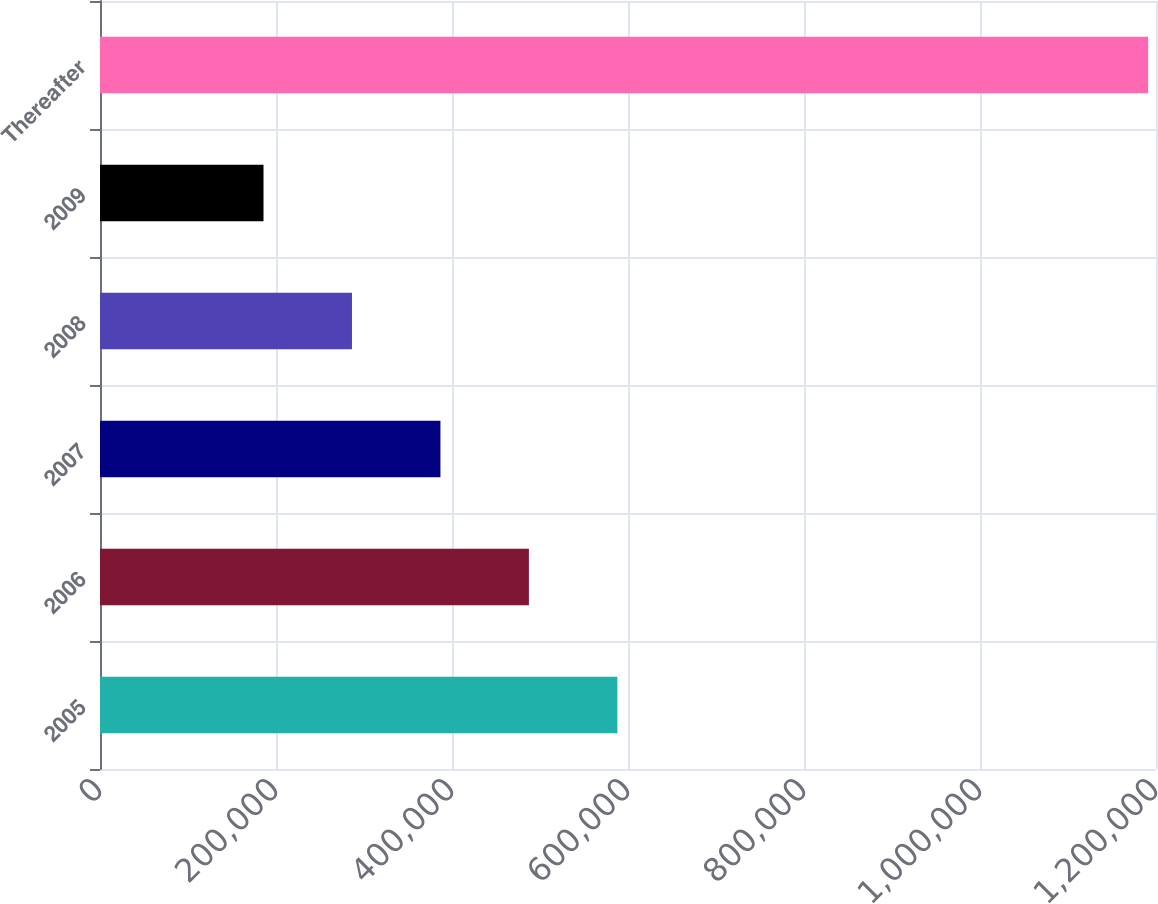<chart> <loc_0><loc_0><loc_500><loc_500><bar_chart><fcel>2005<fcel>2006<fcel>2007<fcel>2008<fcel>2009<fcel>Thereafter<nl><fcel>587920<fcel>487392<fcel>386865<fcel>286337<fcel>185809<fcel>1.19109e+06<nl></chart> 